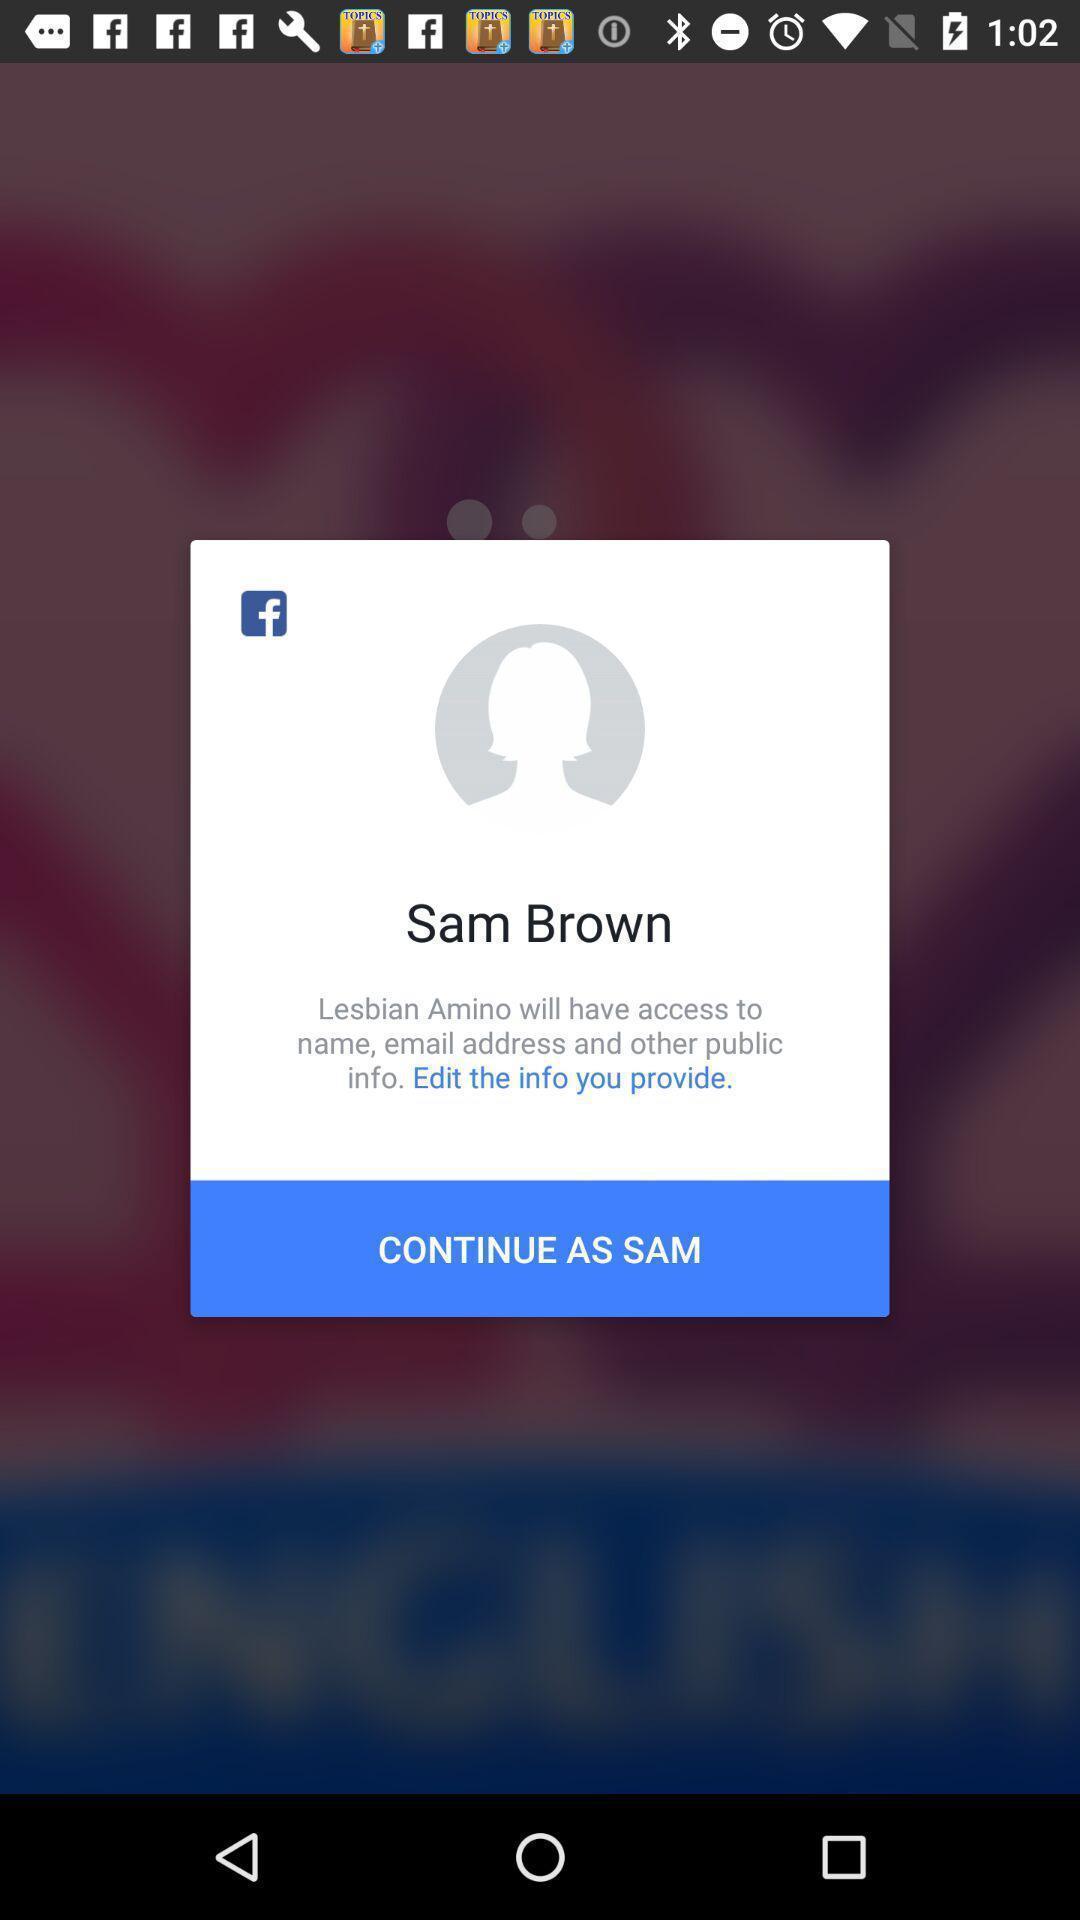Describe the content in this image. Pop-up showing continue option by using a social media app. 